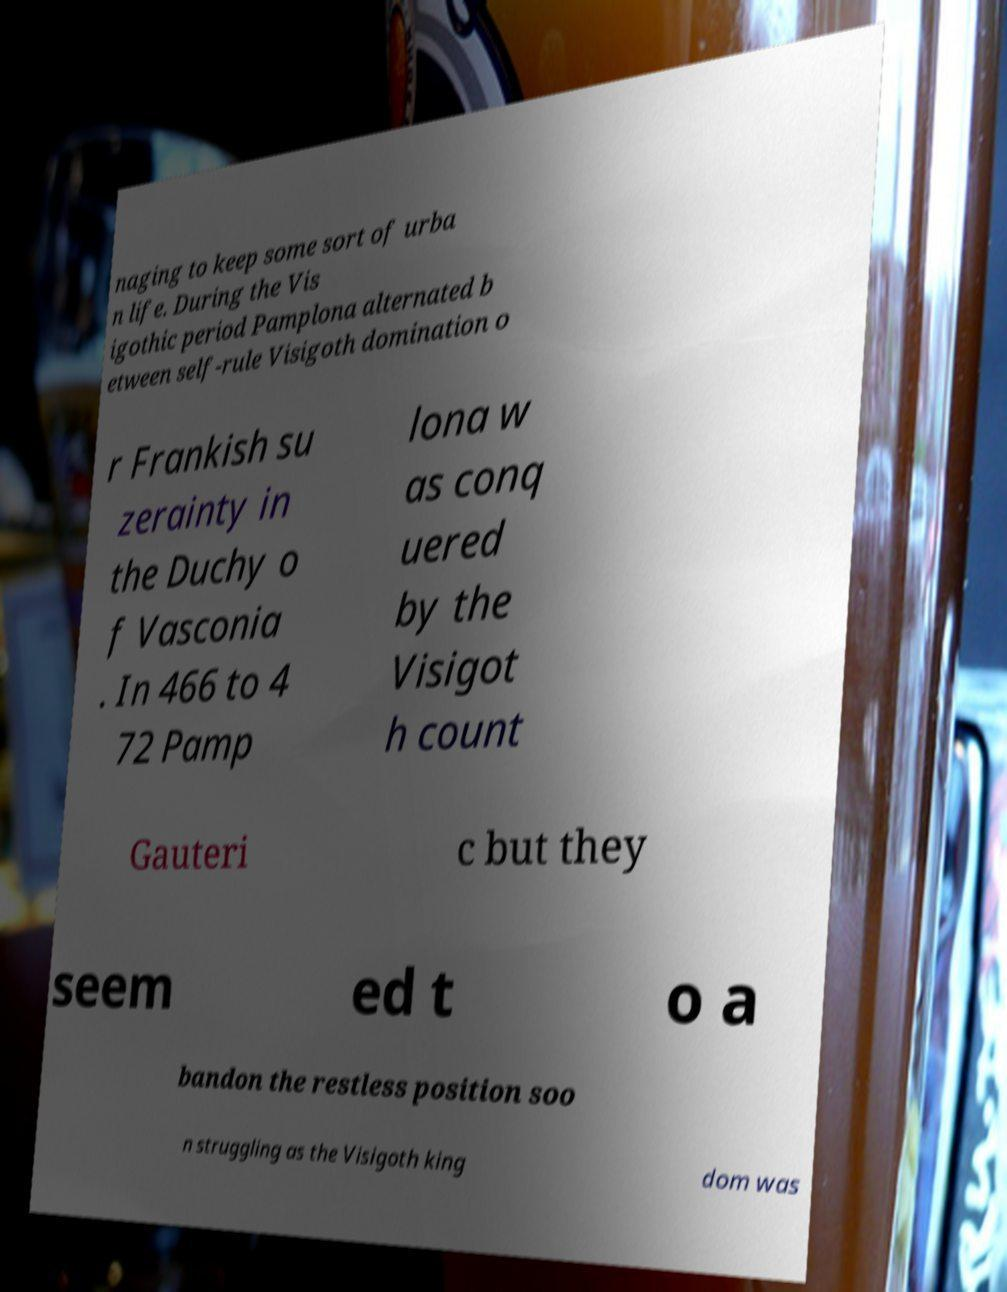Can you accurately transcribe the text from the provided image for me? naging to keep some sort of urba n life. During the Vis igothic period Pamplona alternated b etween self-rule Visigoth domination o r Frankish su zerainty in the Duchy o f Vasconia . In 466 to 4 72 Pamp lona w as conq uered by the Visigot h count Gauteri c but they seem ed t o a bandon the restless position soo n struggling as the Visigoth king dom was 